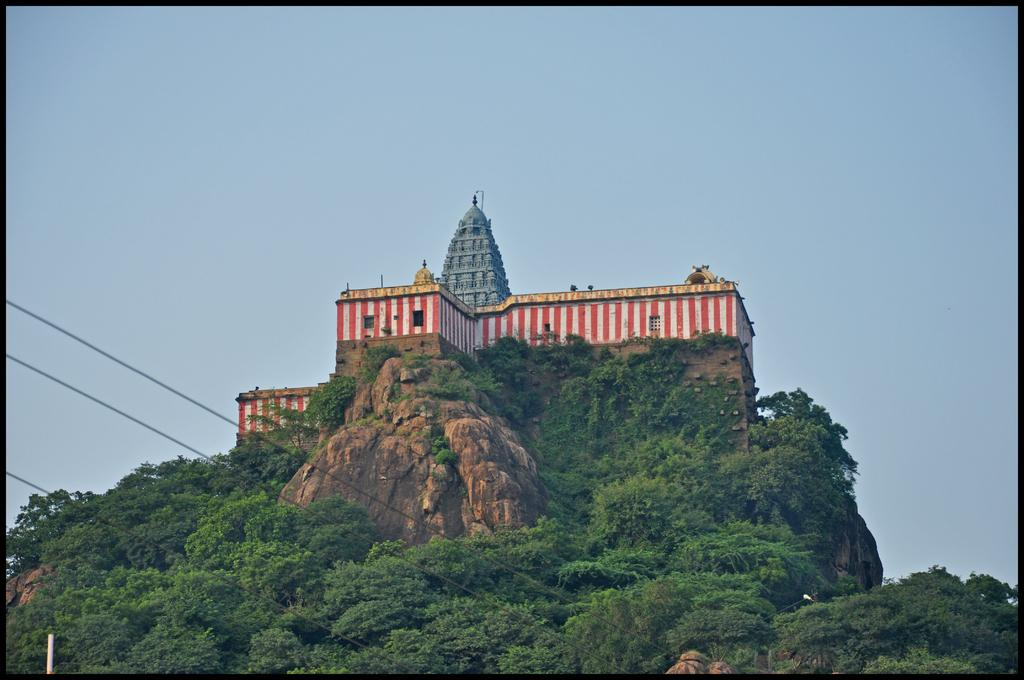What type of structure is located on the hill in the image? There is a building on a hill in the image. What type of vegetation can be seen in the image? There is a group of trees and plants in the image. What man-made objects are visible in the image? Wires and a pole are visible in the image. What is the condition of the sky in the image? The sky is visible in the image and appears cloudy. What type of chalk is being used to draw on the building in the image? There is no chalk or drawing present on the building in the image. Can you see any pickles growing on the plants in the image? There are no pickles present in the image; it features plants and trees. 